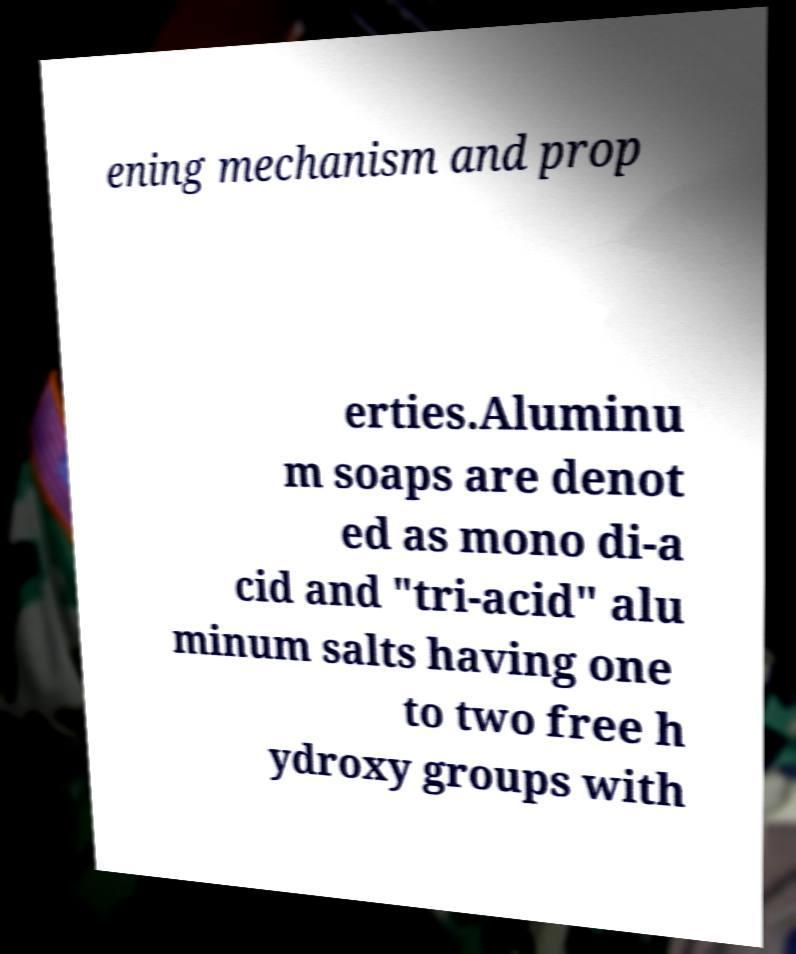Can you accurately transcribe the text from the provided image for me? ening mechanism and prop erties.Aluminu m soaps are denot ed as mono di-a cid and "tri-acid" alu minum salts having one to two free h ydroxy groups with 